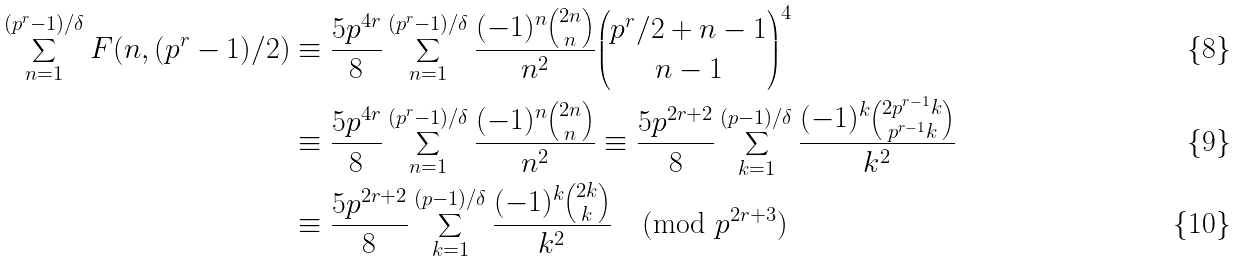<formula> <loc_0><loc_0><loc_500><loc_500>\sum _ { n = 1 } ^ { ( p ^ { r } - 1 ) / \delta } F ( n , ( p ^ { r } - 1 ) / 2 ) & \equiv \frac { 5 p ^ { 4 r } } { 8 } \sum _ { n = 1 } ^ { ( p ^ { r } - 1 ) / \delta } \frac { ( - 1 ) ^ { n } \binom { 2 n } n } { n ^ { 2 } } \binom { p ^ { r } / 2 + n - 1 } { n - 1 } ^ { 4 } \\ & \equiv \frac { 5 p ^ { 4 r } } { 8 } \sum _ { n = 1 } ^ { ( p ^ { r } - 1 ) / \delta } \frac { ( - 1 ) ^ { n } \binom { 2 n } n } { n ^ { 2 } } \equiv \frac { 5 p ^ { 2 r + 2 } } { 8 } \sum _ { k = 1 } ^ { ( p - 1 ) / \delta } \frac { ( - 1 ) ^ { k } \binom { 2 p ^ { r - 1 } k } { p ^ { r - 1 } k } } { k ^ { 2 } } \\ & \equiv \frac { 5 p ^ { 2 r + 2 } } { 8 } \sum _ { k = 1 } ^ { ( p - 1 ) / \delta } \frac { ( - 1 ) ^ { k } \binom { 2 k } { k } } { k ^ { 2 } } \pmod { p ^ { 2 r + 3 } }</formula> 